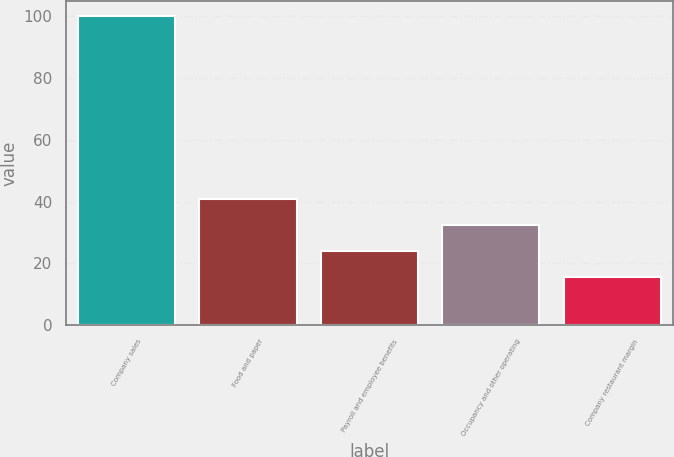Convert chart. <chart><loc_0><loc_0><loc_500><loc_500><bar_chart><fcel>Company sales<fcel>Food and paper<fcel>Payroll and employee benefits<fcel>Occupancy and other operating<fcel>Company restaurant margin<nl><fcel>100<fcel>40.85<fcel>23.95<fcel>32.4<fcel>15.5<nl></chart> 